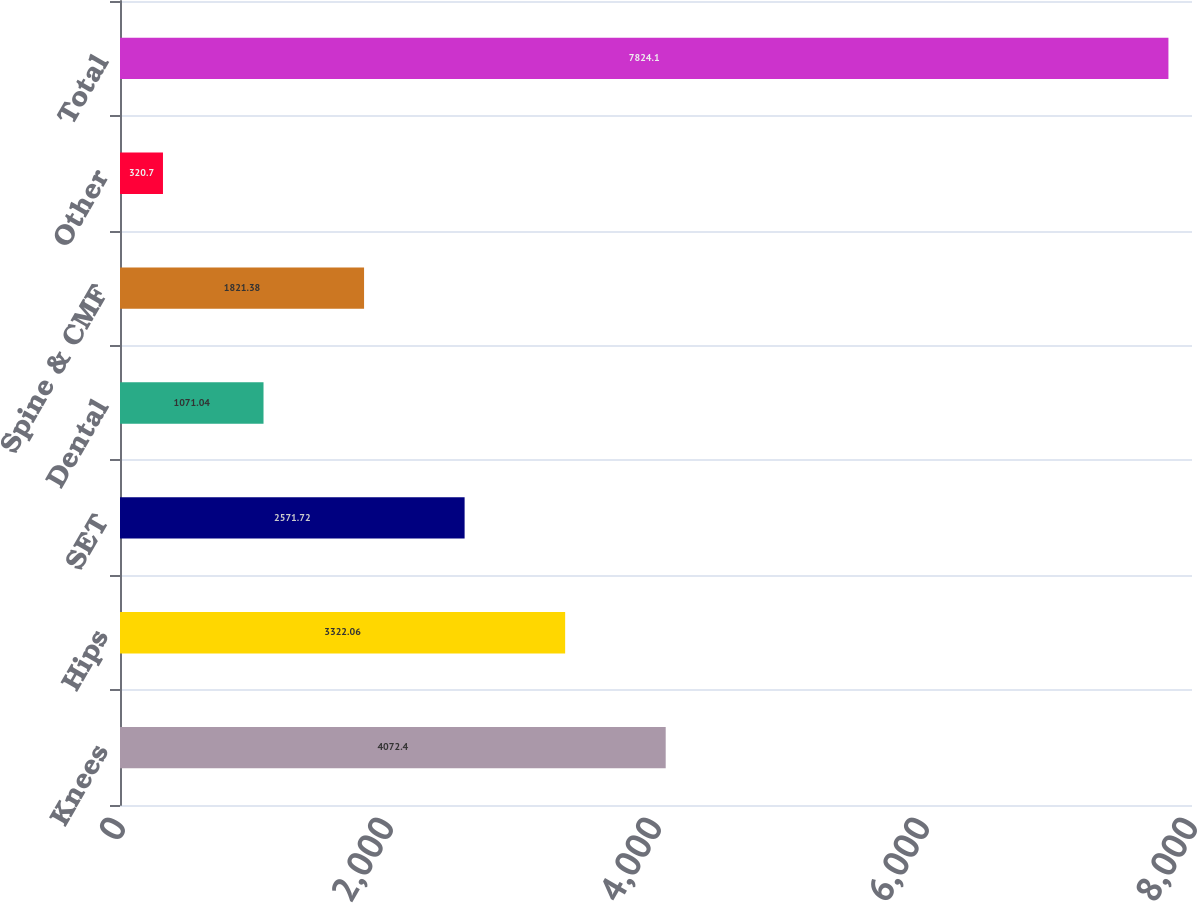Convert chart to OTSL. <chart><loc_0><loc_0><loc_500><loc_500><bar_chart><fcel>Knees<fcel>Hips<fcel>SET<fcel>Dental<fcel>Spine & CMF<fcel>Other<fcel>Total<nl><fcel>4072.4<fcel>3322.06<fcel>2571.72<fcel>1071.04<fcel>1821.38<fcel>320.7<fcel>7824.1<nl></chart> 